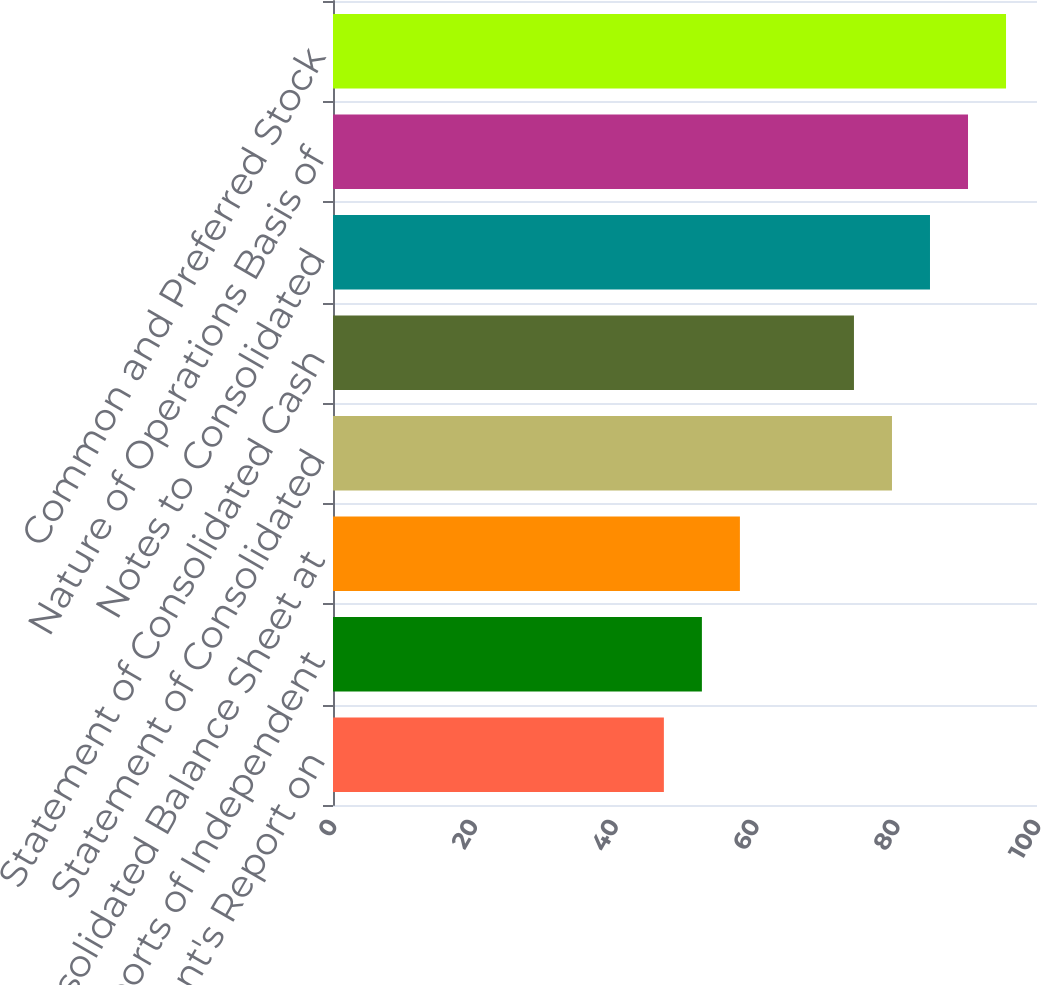Convert chart. <chart><loc_0><loc_0><loc_500><loc_500><bar_chart><fcel>Management's Report on<fcel>Reports of Independent<fcel>Consolidated Balance Sheet at<fcel>Statement of Consolidated<fcel>Statement of Consolidated Cash<fcel>Notes to Consolidated<fcel>Nature of Operations Basis of<fcel>Common and Preferred Stock<nl><fcel>47<fcel>52.4<fcel>57.8<fcel>79.4<fcel>74<fcel>84.8<fcel>90.2<fcel>95.6<nl></chart> 